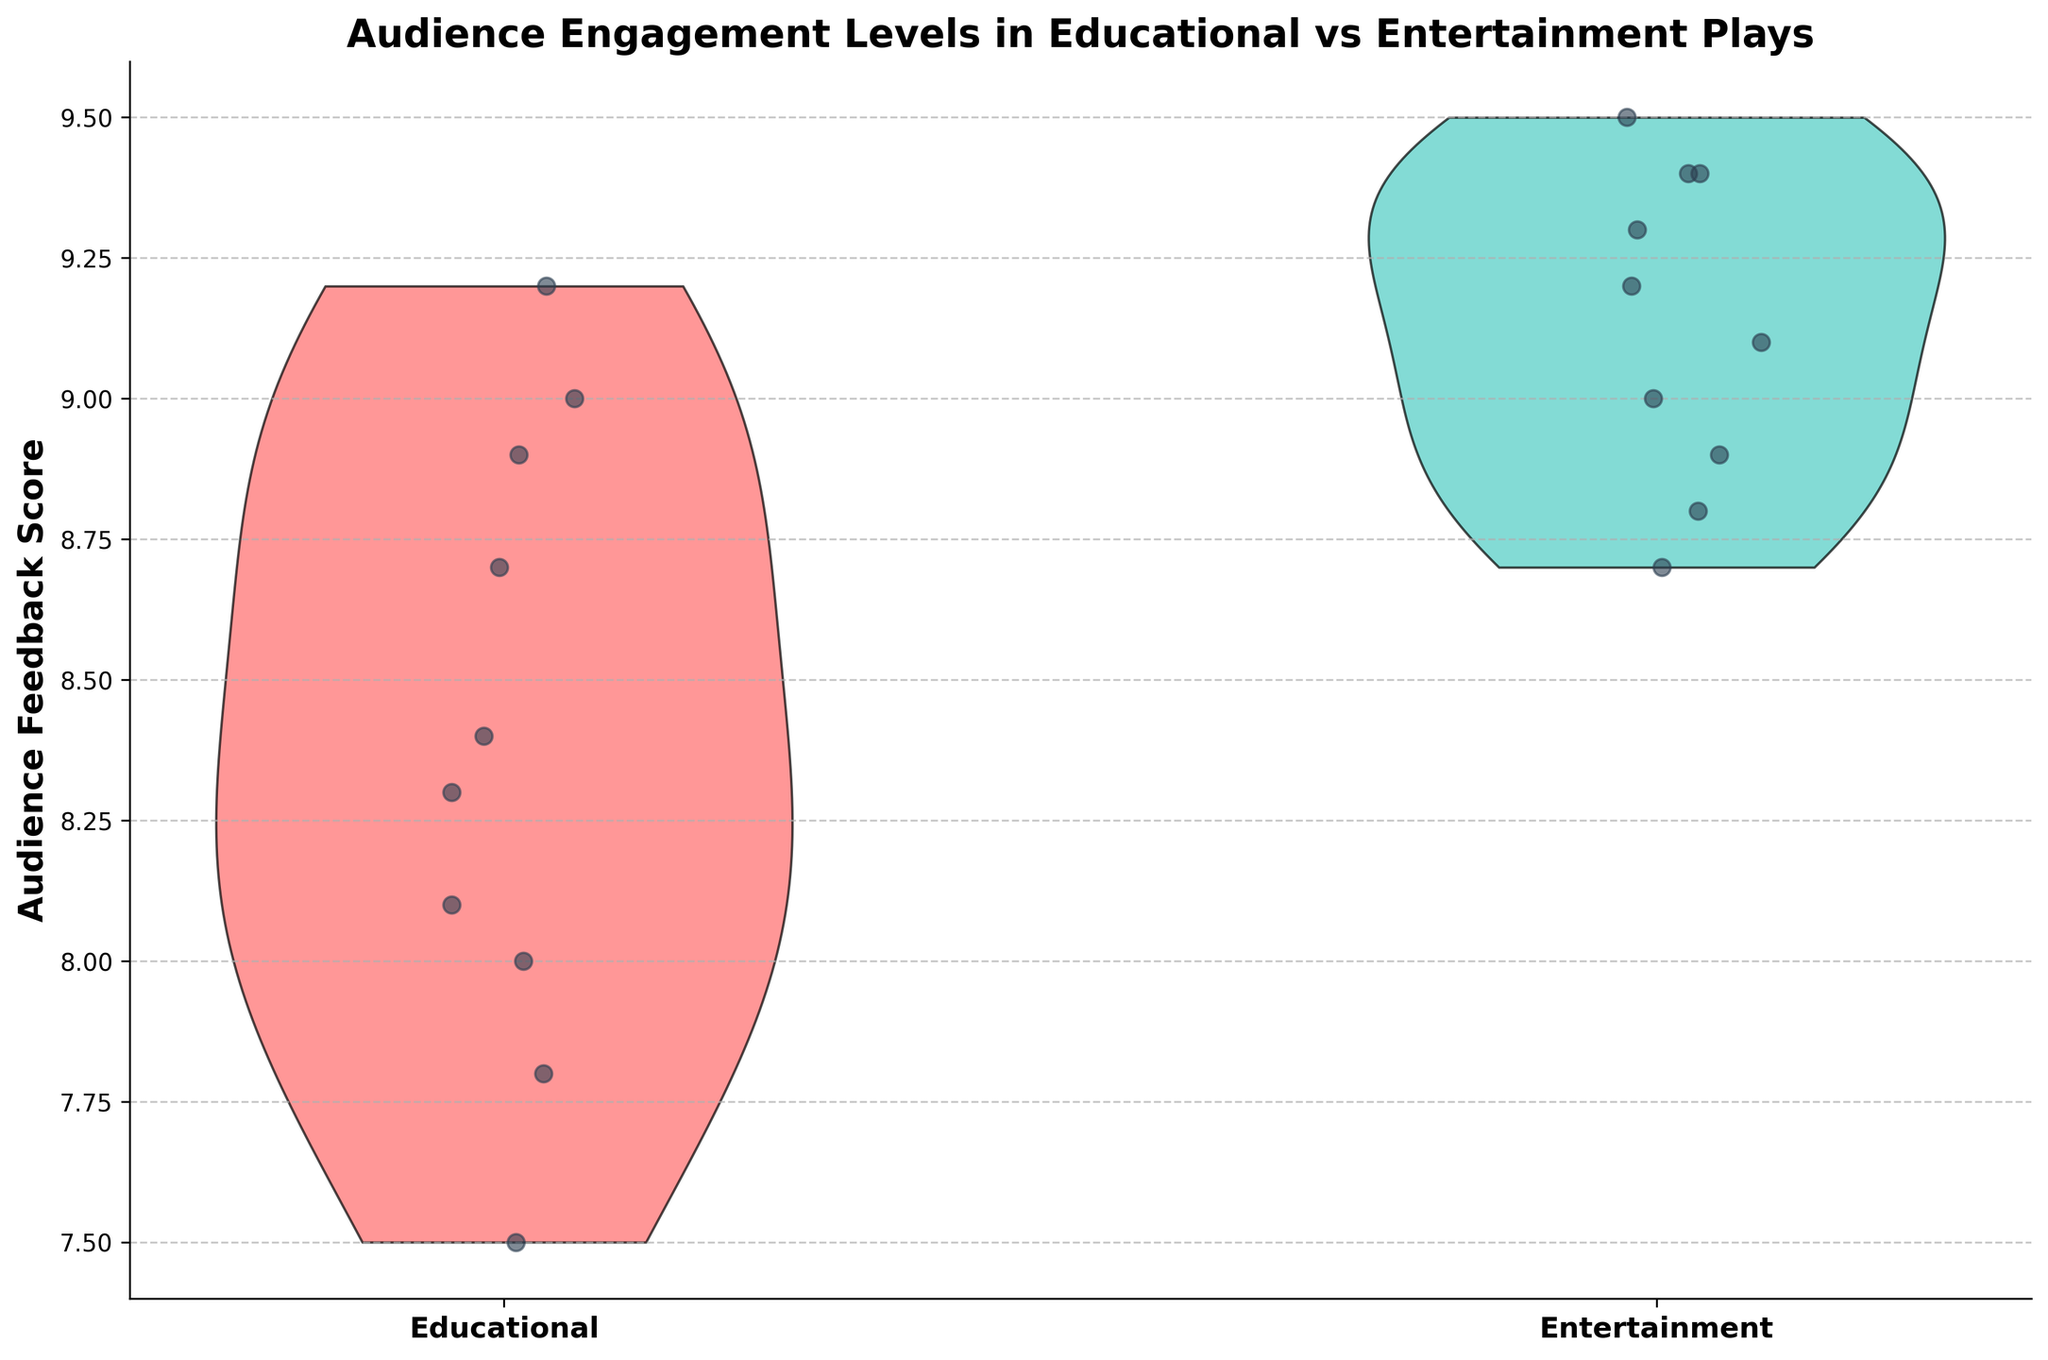What's the title of the figure? The title is usually found at the top of the figure, conveying the main topic being visualized.
Answer: Audience Engagement Levels in Educational vs Entertainment Plays How many play types are presented in the figure? There are two blocks of violin plots, each representing a distinct play type.
Answer: 2 What colors are used for the violin plots? The colors filling the violin plots are visually distinctive. One is a shade of red, and the other is a shade of green.
Answer: Red and green Which play type shows a generally higher range of audience feedback scores? By assessing the width and the upper bounds of the violin plots, the 'Entertainment' play type appears to have higher scores.
Answer: Entertainment How does the highest feedback score in Educational plays compare to the highest in Entertainment plays? Find the uppermost points of each violin plot to compare their vertical positions.
Answer: The highest score in Educational is lower What's the general spread of scores like in educational plays? The 'Educational' violin plot has a visible width and distribution of points, indicating the spread of data.
Answer: 7.5 to 9.2 Which director(s) have contributed the most to educational plays based on the plot points? More jittered points representing feedback scores under certain directors show their contributions.
Answer: Ava DuVernay and Lin-Manuel Miranda Calculate the average feedback score for entertainment plays. Sum up all the audience feedback scores for entertainment plays and divide by the number of entries: (9.5 + 9.1 + 8.9 + 9.3 + 8.8 + 9.0 + 9.2 + 9.4 + 9.4 + 8.7)/10 = 9.13
Answer: 9.13 Which play type has the most tightly grouped feedback scores? The violin plot showing a narrower spread indicates less variability in feedback scores.
Answer: Entertainment Based on the violin plots, are the median scores visible, and can they be deduced from the figure? Typically violin plots may or may not show a distinct mark for the median, but the central tendency can be inferred.
Answer: No, medians are not explicitly marked 